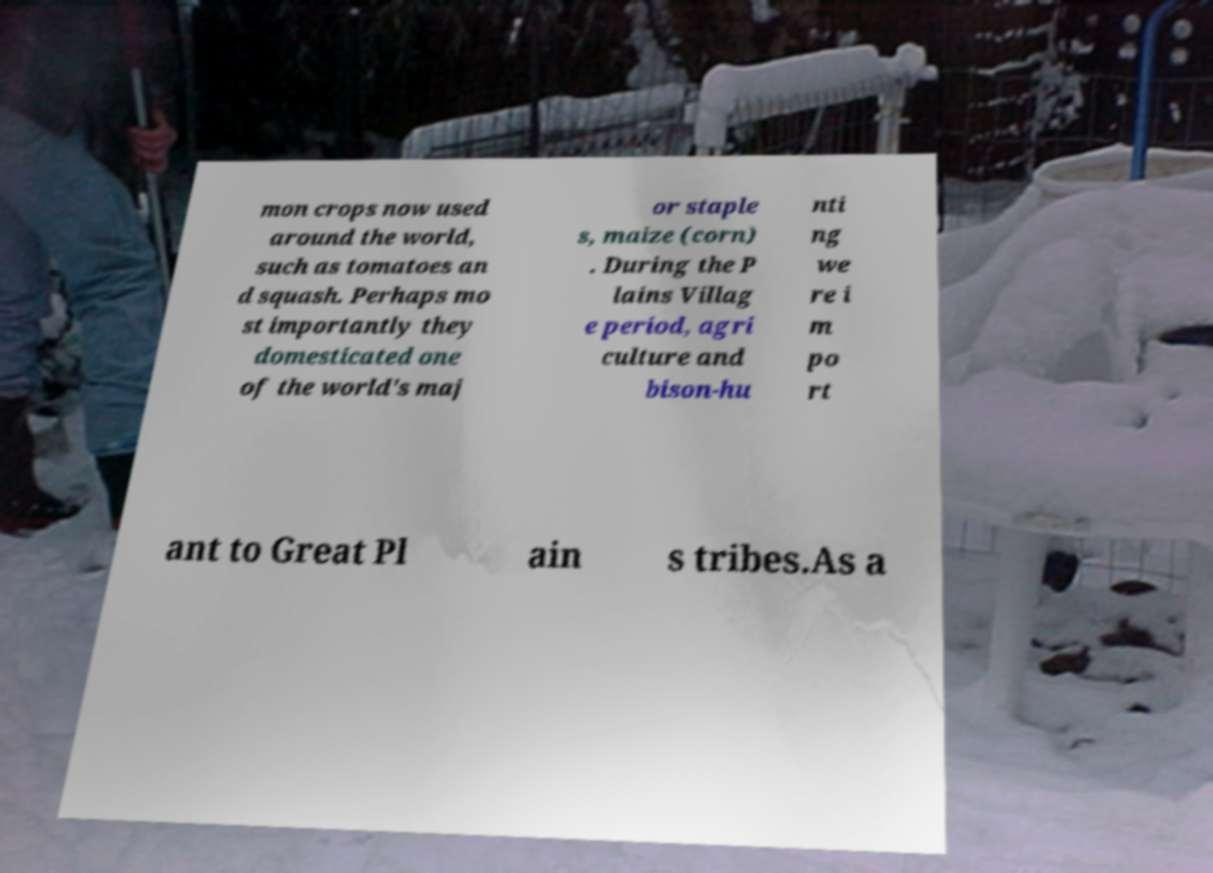Please read and relay the text visible in this image. What does it say? mon crops now used around the world, such as tomatoes an d squash. Perhaps mo st importantly they domesticated one of the world's maj or staple s, maize (corn) . During the P lains Villag e period, agri culture and bison-hu nti ng we re i m po rt ant to Great Pl ain s tribes.As a 